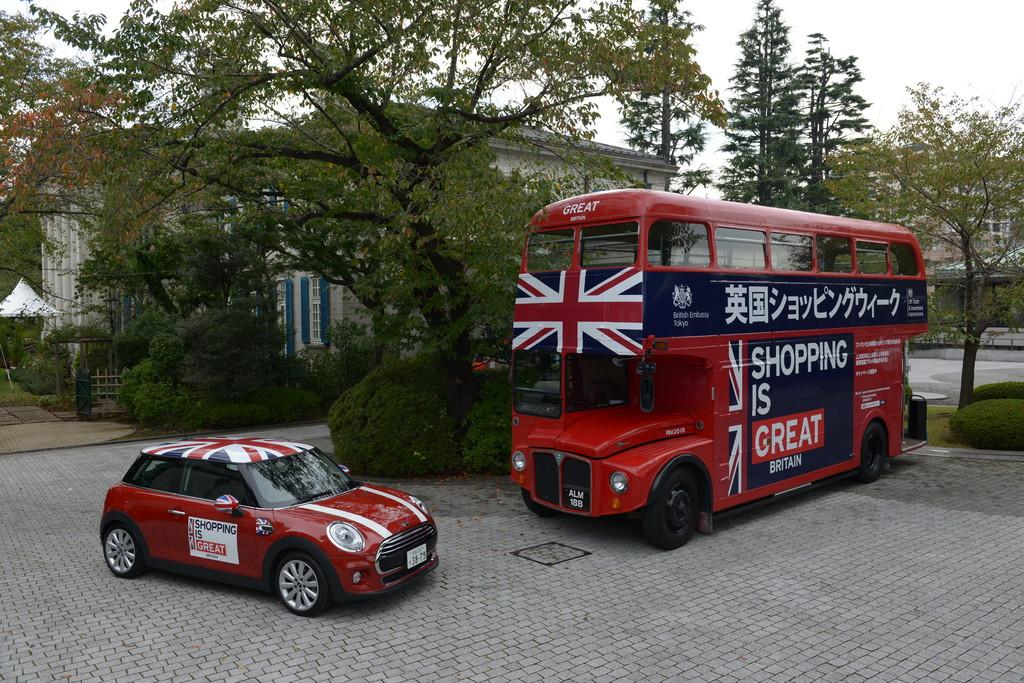What type of vehicles are present in the image? There is a car and a bus in the image. Where are the car and bus located? Both the car and bus are on a floor. What can be seen in the background of the image? There are trees and a house in the background of the image. What type of farm animals can be seen grazing near the car and bus in the image? There are no farm animals present in the image; it features include a car, a bus, a floor, trees, and a house. 